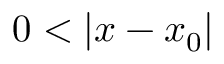<formula> <loc_0><loc_0><loc_500><loc_500>0 < | x - x _ { 0 } |</formula> 